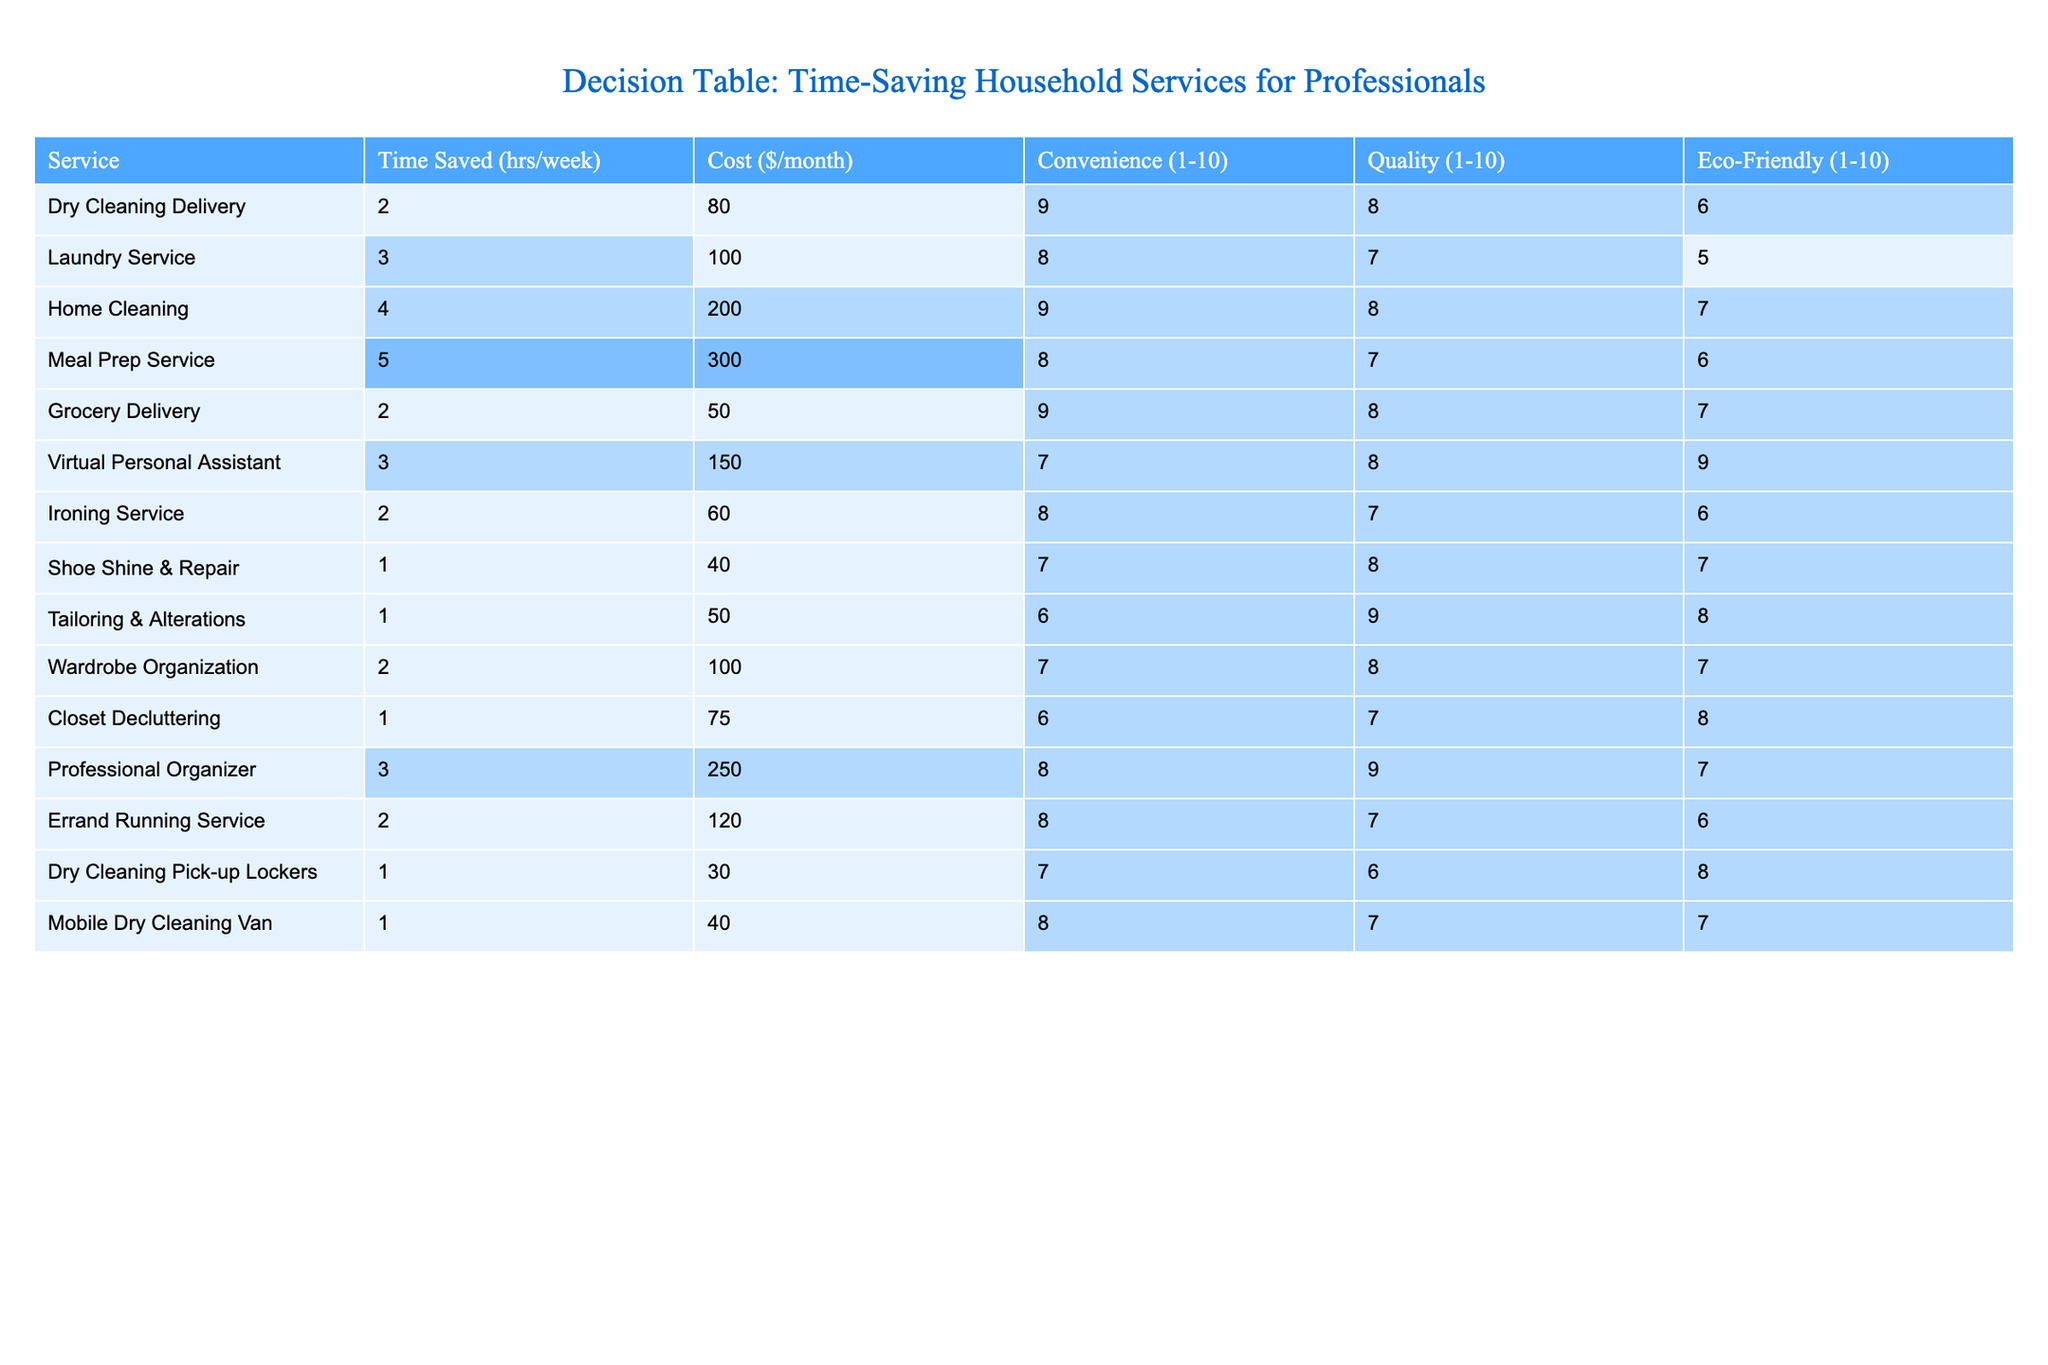What is the most time-saving service on the list? The time saved for each service is listed in the "Time Saved (hrs/week)" column. The highest value in this column is 5 hours per week, which corresponds to the Meal Prep Service.
Answer: Meal Prep Service What is the average cost of the services that save at least 2 hours a week? To find the average cost, first list the eligible services and their costs: Dry Cleaning Delivery ($80), Laundry Service ($100), Home Cleaning ($200), Meal Prep Service ($300), Grocery Delivery ($50), Virtual Personal Assistant ($150), Ironing Service ($60), Wardrobe Organization ($100), Errand Running Service ($120). The total cost is $80 + $100 + $200 + $300 + $50 + $150 + $60 + $100 + $120 = $1160, and there are 9 services, so the average cost is $1160/9 = $128.89.
Answer: 128.89 Which service has the highest convenience score? The convenience scores are in the "Convenience (1-10)" column. The highest score is 9, which is shared by Dry Cleaning Delivery and Home Cleaning.
Answer: Dry Cleaning Delivery and Home Cleaning Is the Virtual Personal Assistant service eco-friendly? The eco-friendliness score for the Virtual Personal Assistant is 9 according to the "Eco-Friendly (1-10)" column. Therefore, this service is considered eco-friendly.
Answer: Yes How much more does the Meal Prep Service cost compared to the Grocery Delivery? The cost of the Meal Prep Service is $300, and the cost of Grocery Delivery is $50. The difference is $300 - $50 = $250.
Answer: 250 How many services have a quality score greater than 8? Reviewing the "Quality (1-10)" column, the services with scores greater than 8 are: Dry Cleaning Delivery (8), Home Cleaning (8), Virtual Personal Assistant (8), Tailoring & Alterations (9), Professional Organizer (9). This totals 3 services with a score greater than 8.
Answer: 3 What is the total time saved per week if a busy professional uses all services listed? We sum all the time saved values in the "Time Saved (hrs/week)" column: 2 + 3 + 4 + 5 + 2 + 3 + 2 + 1 + 1 + 2 + 1 + 3 + 2 + 1 = 26 hours of time saved per week if using all services.
Answer: 26 Which service offers the best combination of time-saving and cost? To determine this, we compare the Time Saved to Cost for each service. Dividing time saved by cost, we see that services offering the best value relative to cost tend to be those with a high time savings ratio. For example, Grocery Delivery gives 2 hours for $50, which is 0.04 hours per dollar, while the Meal Prep Service has the lowest value at 0.017 hours per dollar. Therefore, Grocery Delivery offers the best combination of time-saving and cost.
Answer: Grocery Delivery 